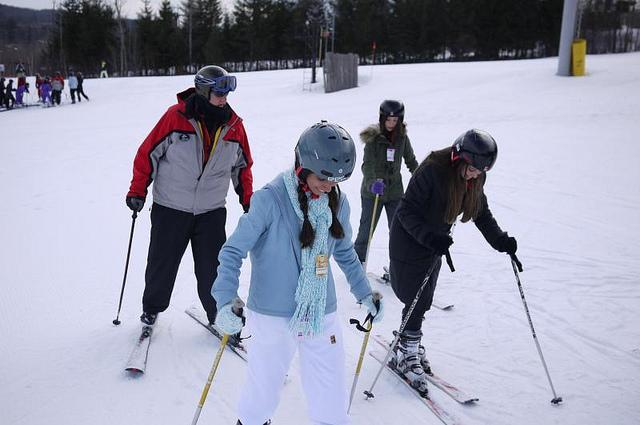What is this group ready to do? ski 